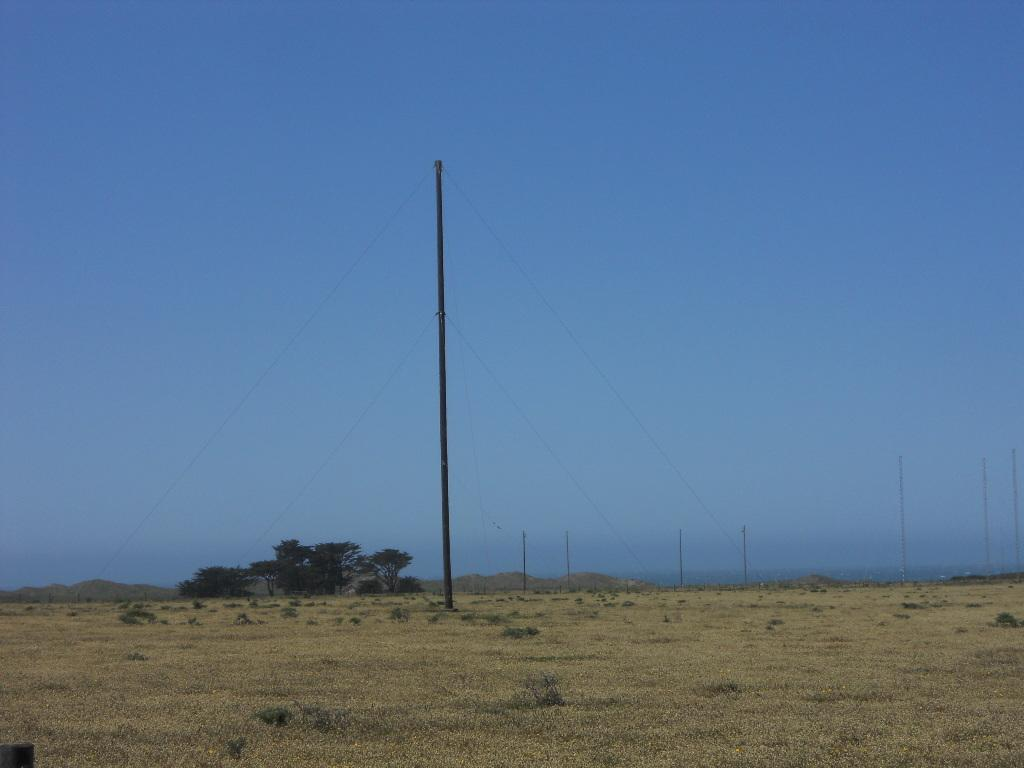What is on the ground in the image? There is a pole and plants on the ground in the image. What type of vegetation is visible in the image? There are plants and trees visible in the image. What can be seen in the background of the image? The sky is visible in the background of the image. What advice is the pole giving to the plants in the image? There is no indication in the image that the pole is giving advice to the plants, as objects do not communicate in this manner. 